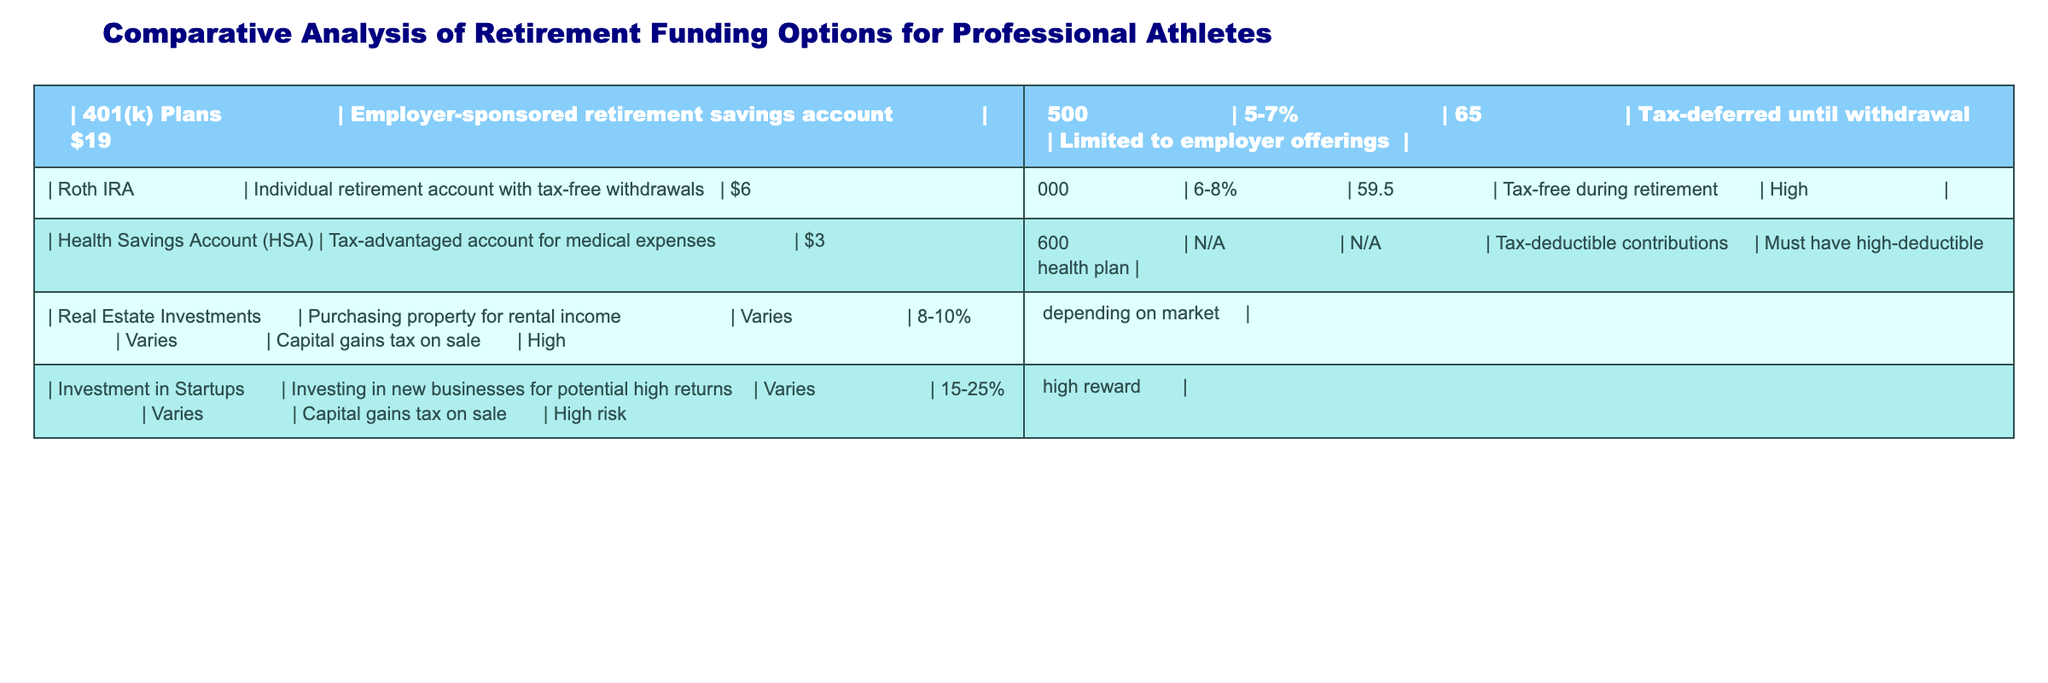What is the maximum contribution limit for a 401(k) plan? The table specifies that the maximum contribution limit for a 401(k) plan is $19,500.
Answer: $19,500 Which retirement option offers tax-free withdrawals during retirement? The Roth IRA is the only option listed that specifically offers tax-free withdrawals during retirement.
Answer: Roth IRA What is the minimum age for penalty-free withdrawals from a Roth IRA? The table shows that the minimum age for penalty-free withdrawals from a Roth IRA is 59.5 years.
Answer: 59.5 If a person invests in real estate, what is the average estimated return on investment? The table indicates that real estate investments offer an average return of 8-10%. To calculate an average, we take (8+10)/2 = 9%.
Answer: 9% Is it true that Health Savings Accounts (HSA) require holders to have a high-deductible health plan? According to the table, HSAs do have the requirement that the holder must have a high-deductible health plan.
Answer: Yes What is the estimated return on investment in startups compared to real estate investments? The table shows that the estimated return on investment for startups is 15-25%, while for real estate it is 8-10%. Thus, the startup's return is higher, as both ranges can be compared directly.
Answer: Startups have higher returns What is the contribution limit for a Health Savings Account (HSA)? The table specifies that the contribution limit for an HSA is $3,600.
Answer: $3,600 What is the age at which funds can be withdrawn from a 401(k) plan without penalty? The table states that funds can typically be withdrawn from a 401(k) without penalty at age 65, as shown in the corresponding row.
Answer: 65 Which retirement option has the highest risk level? The table indicates that investments in startups are classified as having high risk, as they are noted for their potential high returns but also significant risk.
Answer: Investment in Startups If someone wants to prioritize liquidity in their investment, which option would be recommended based on the table? Based on the table, Roth IRA would be recommended since it offers tax-free withdrawals during retirement, enhancing liquidity compared to other options with restrictions (e.g., 401(k) plan and real estate).
Answer: Roth IRA 